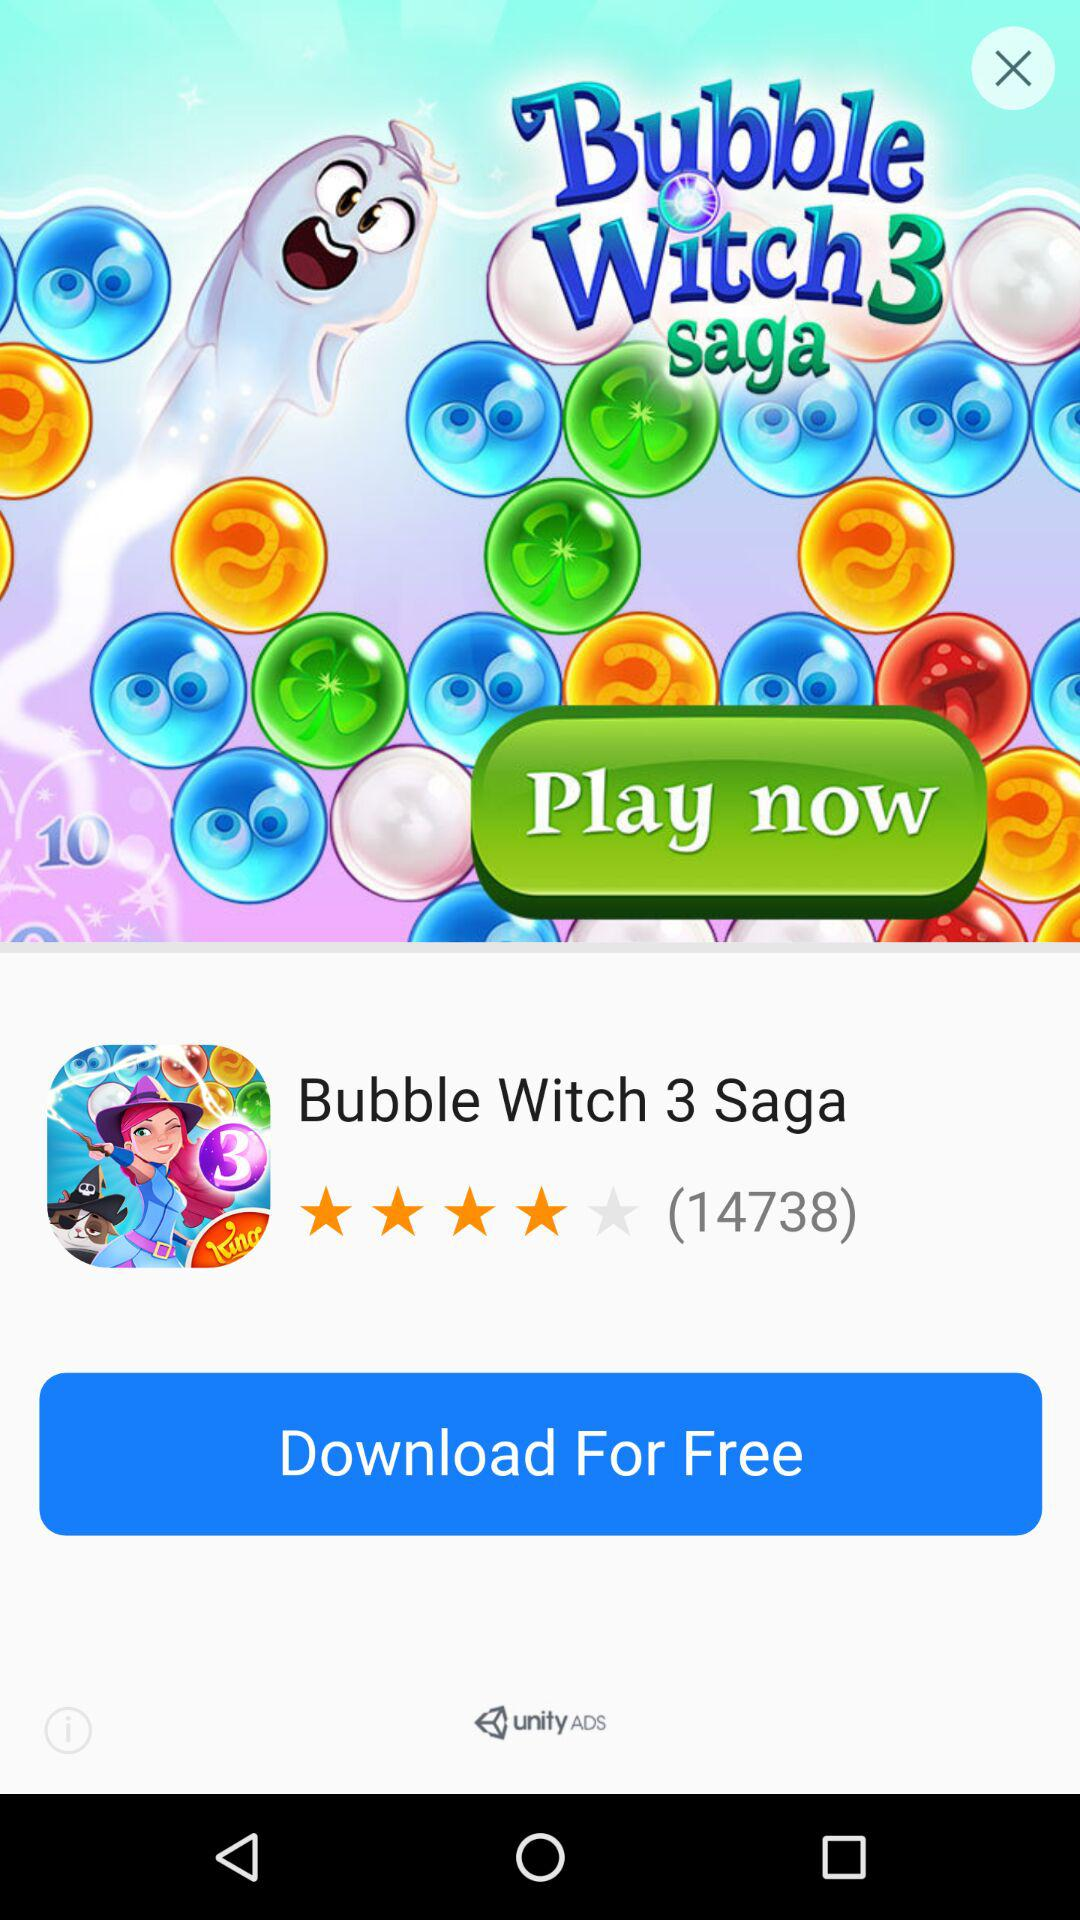How many people like it? There are 14738 people who like it. 